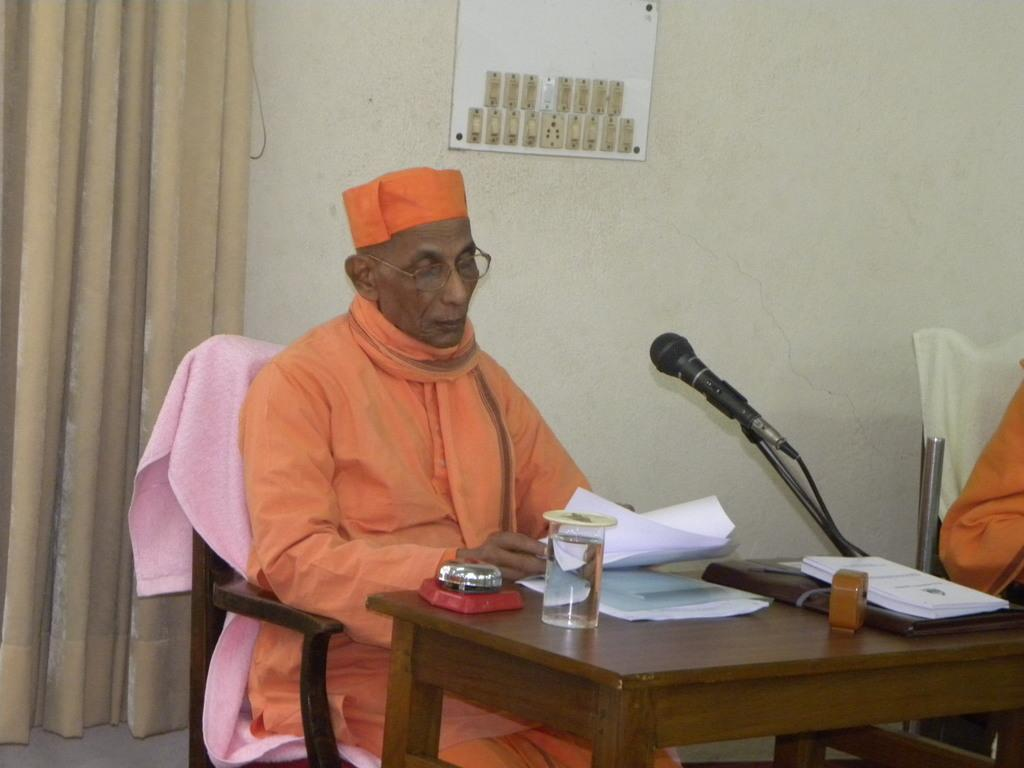What is the person in the image doing? The person is sitting on a chair. What is on the table in the image? There is a microphone, papers, a book, and a glass on the table. What is on the wall in the background? There is a switch board on the wall. What can be seen in the background of the image? There are curtains in the background. What is visible on the floor? The floor is visible. What type of wax can be seen dripping from the microphone in the image? There is no wax dripping from the microphone in the image. 